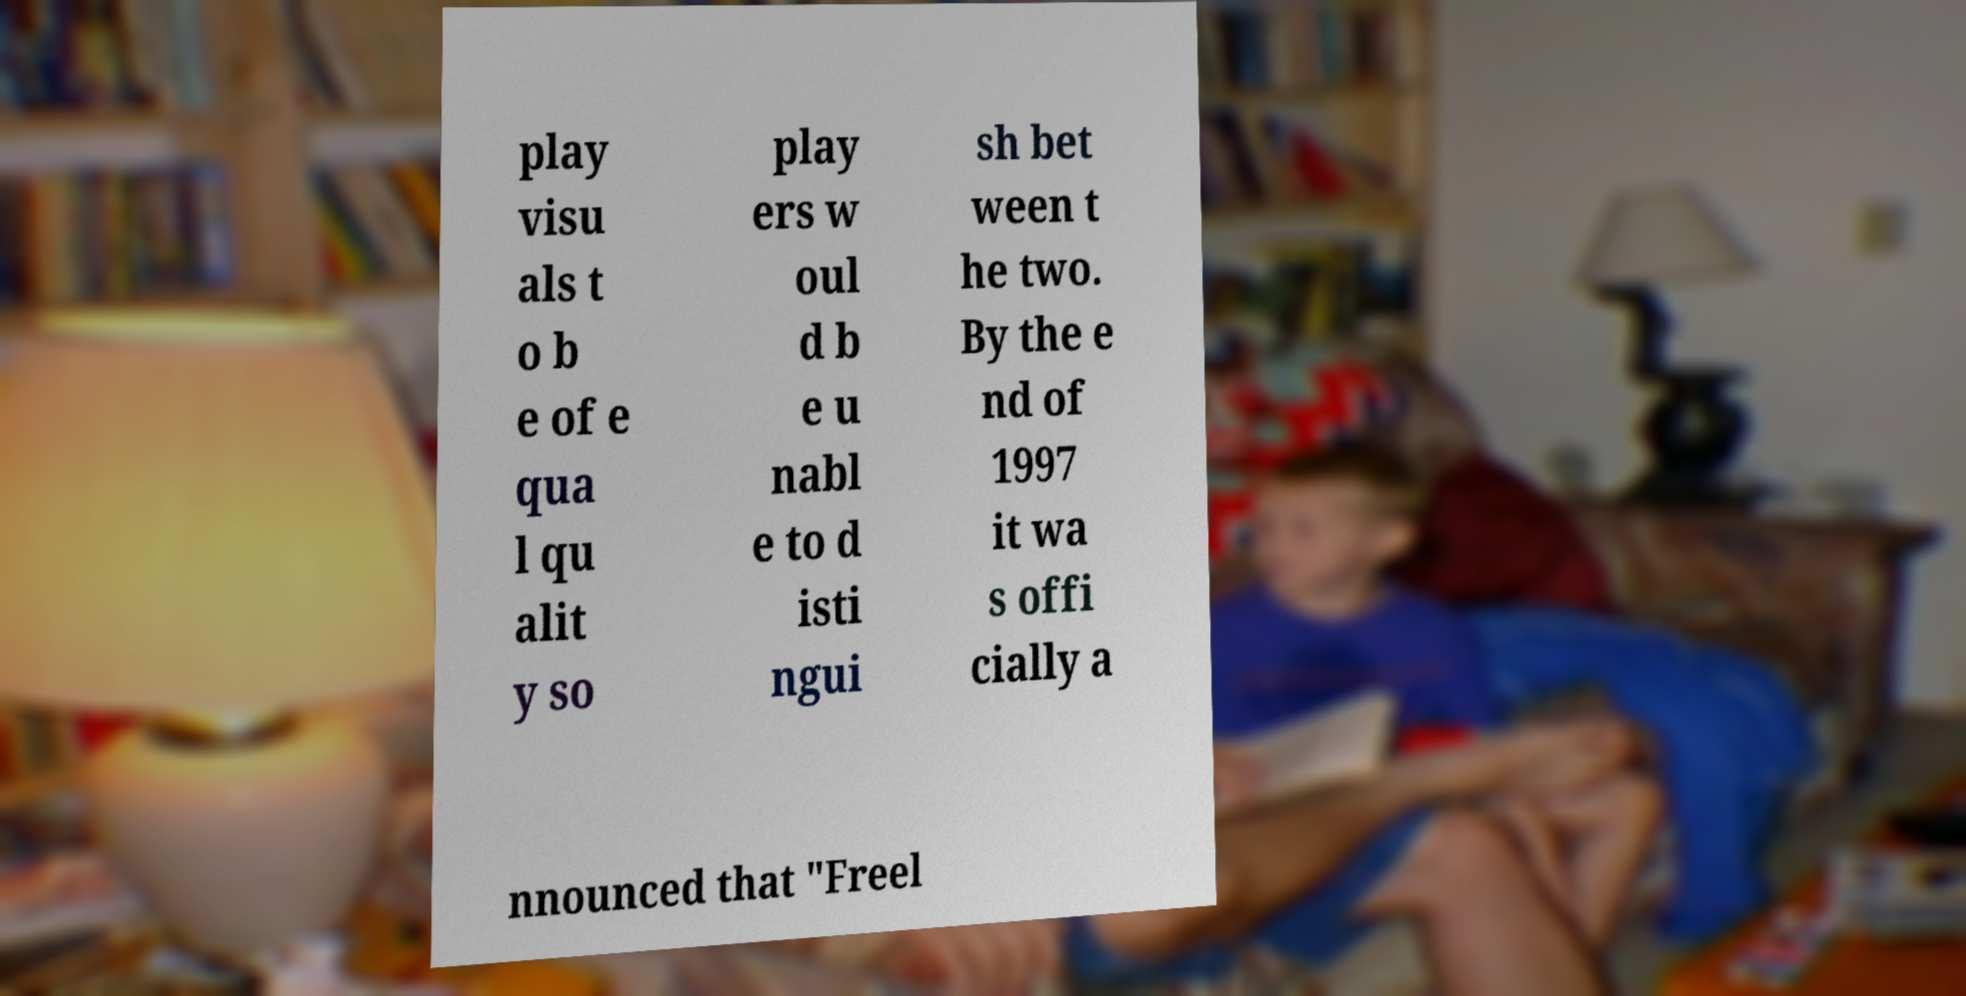Please read and relay the text visible in this image. What does it say? play visu als t o b e of e qua l qu alit y so play ers w oul d b e u nabl e to d isti ngui sh bet ween t he two. By the e nd of 1997 it wa s offi cially a nnounced that "Freel 